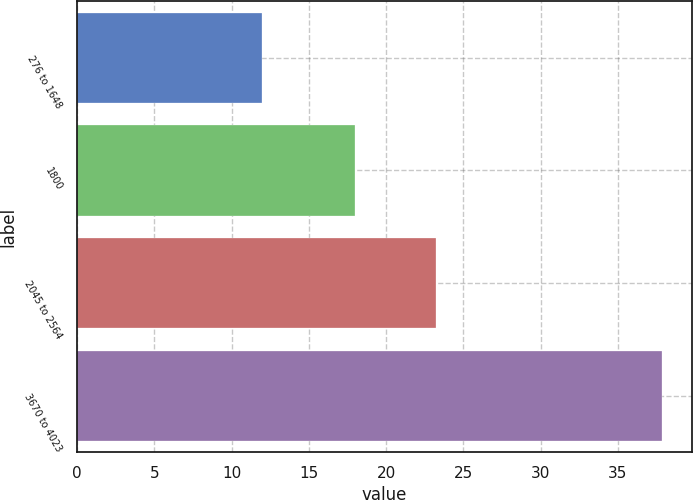Convert chart. <chart><loc_0><loc_0><loc_500><loc_500><bar_chart><fcel>276 to 1648<fcel>1800<fcel>2045 to 2564<fcel>3670 to 4023<nl><fcel>11.95<fcel>18<fcel>23.23<fcel>37.88<nl></chart> 